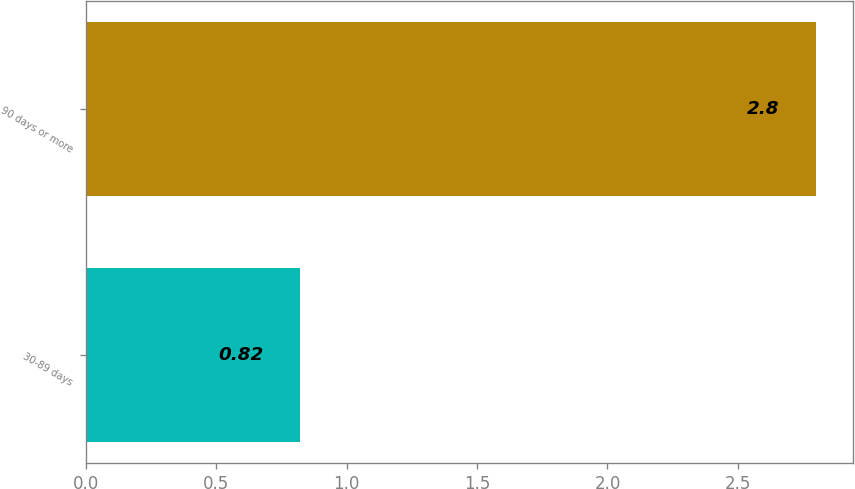Convert chart. <chart><loc_0><loc_0><loc_500><loc_500><bar_chart><fcel>30-89 days<fcel>90 days or more<nl><fcel>0.82<fcel>2.8<nl></chart> 